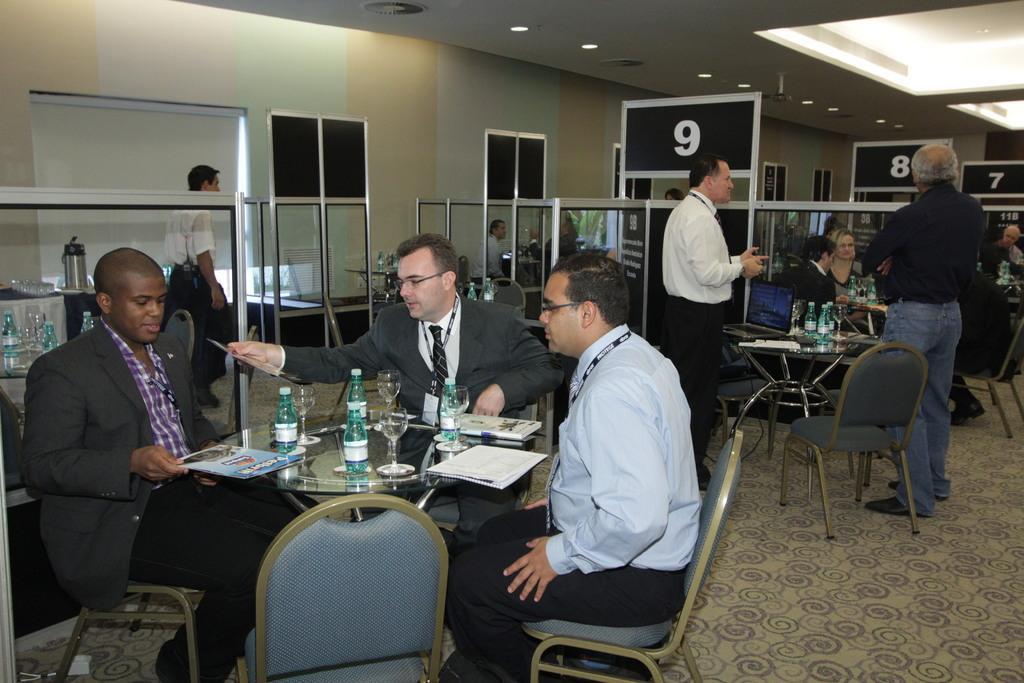Could you give a brief overview of what you see in this image? As we can see in the image there is a wall, few people standing and sitting here and there and there are chairs and tables. On tables there are books, papers, glasses and bottles. 